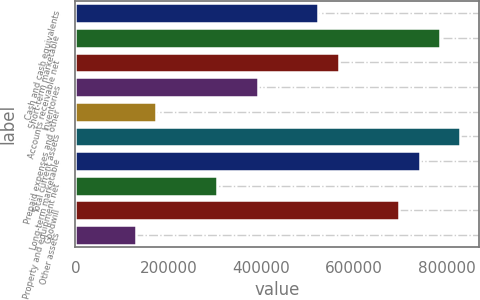<chart> <loc_0><loc_0><loc_500><loc_500><bar_chart><fcel>Cash and cash equivalents<fcel>Short-term marketable<fcel>Accounts receivable net<fcel>Inventories<fcel>Prepaid expenses and other<fcel>Total current assets<fcel>Long-term marketable<fcel>Property and equipment net<fcel>Goodwill<fcel>Other assets<nl><fcel>523318<fcel>784862<fcel>566908<fcel>392545<fcel>174591<fcel>828453<fcel>741272<fcel>305364<fcel>697681<fcel>131000<nl></chart> 